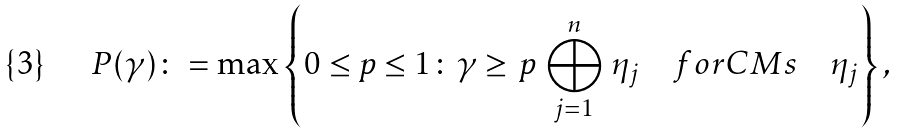Convert formula to latex. <formula><loc_0><loc_0><loc_500><loc_500>P ( \gamma ) \colon = \max \left \{ 0 \leq p \leq 1 \colon \gamma \geq \, p \, \bigoplus _ { j = 1 } ^ { n } \, \eta _ { j } \quad f o r C M s \quad \eta _ { j } \right \} ,</formula> 